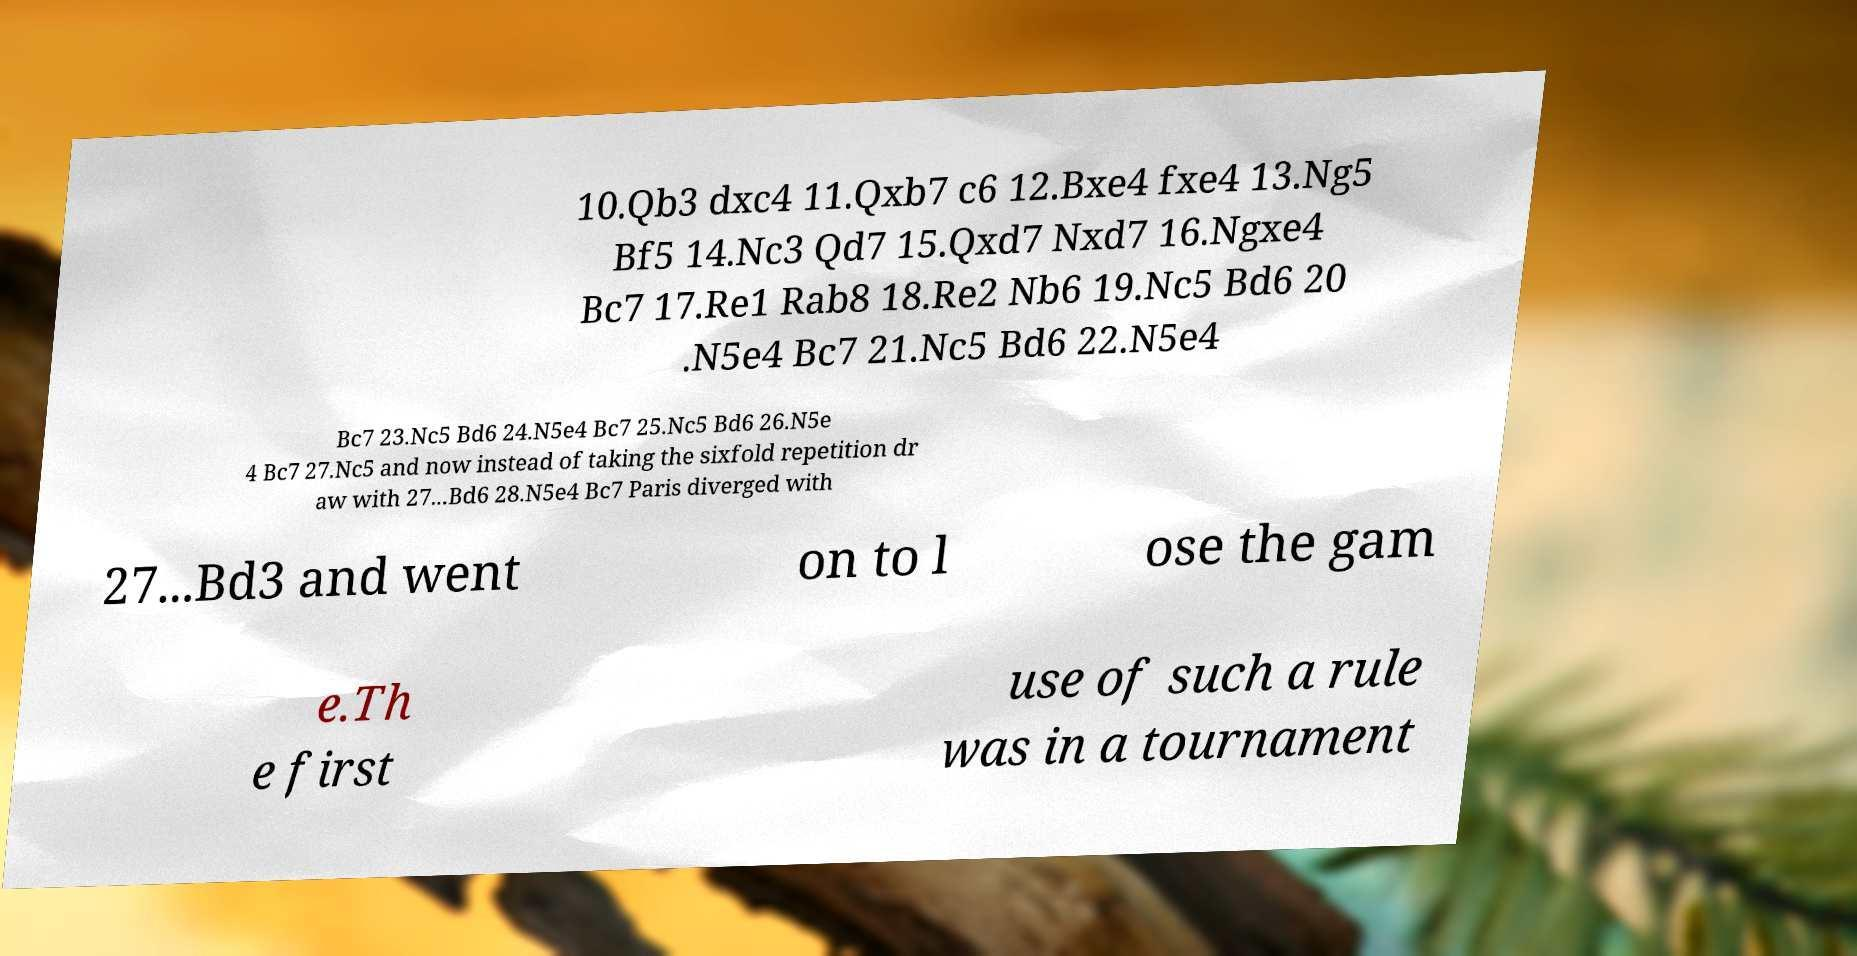What messages or text are displayed in this image? I need them in a readable, typed format. 10.Qb3 dxc4 11.Qxb7 c6 12.Bxe4 fxe4 13.Ng5 Bf5 14.Nc3 Qd7 15.Qxd7 Nxd7 16.Ngxe4 Bc7 17.Re1 Rab8 18.Re2 Nb6 19.Nc5 Bd6 20 .N5e4 Bc7 21.Nc5 Bd6 22.N5e4 Bc7 23.Nc5 Bd6 24.N5e4 Bc7 25.Nc5 Bd6 26.N5e 4 Bc7 27.Nc5 and now instead of taking the sixfold repetition dr aw with 27...Bd6 28.N5e4 Bc7 Paris diverged with 27...Bd3 and went on to l ose the gam e.Th e first use of such a rule was in a tournament 